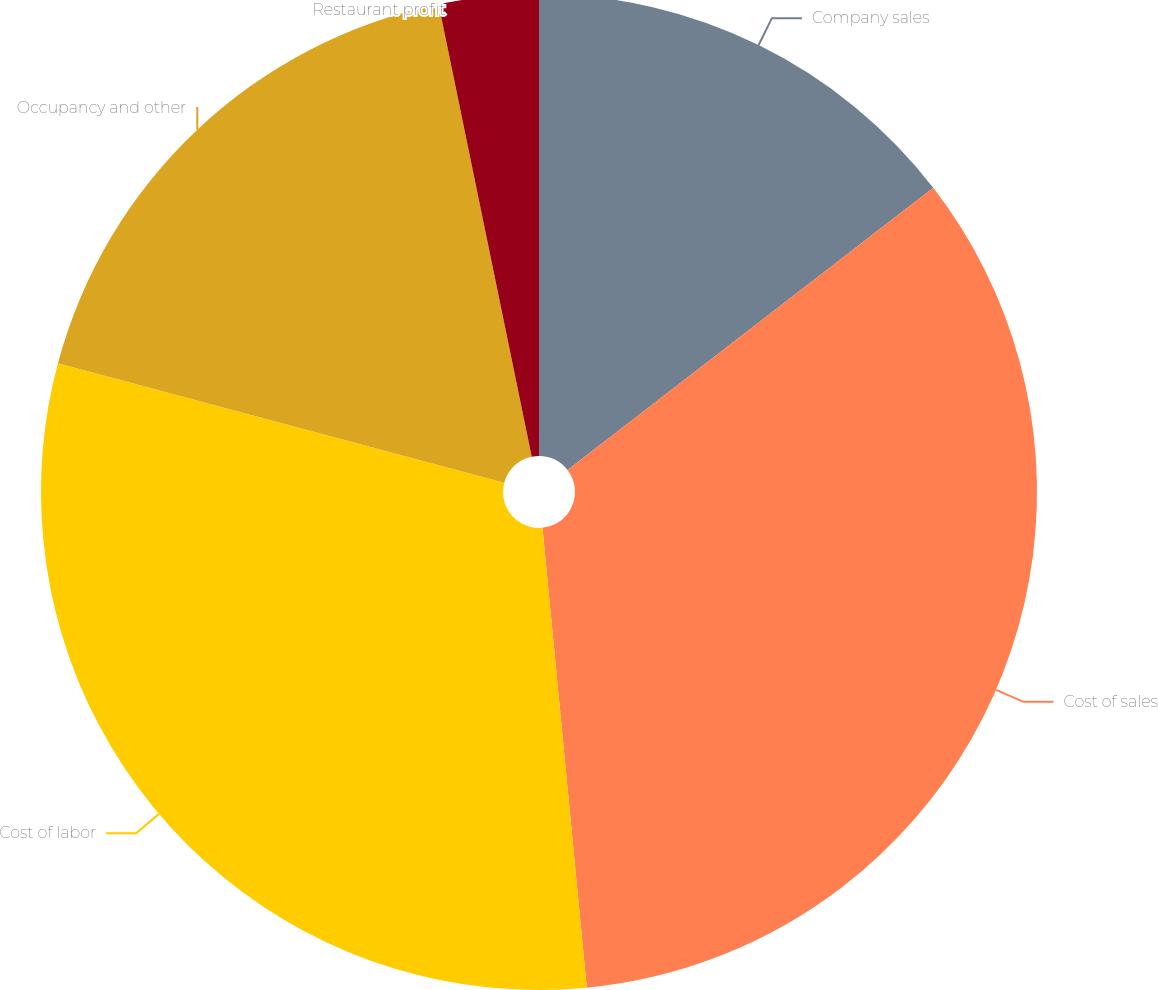Convert chart. <chart><loc_0><loc_0><loc_500><loc_500><pie_chart><fcel>Company sales<fcel>Cost of sales<fcel>Cost of labor<fcel>Occupancy and other<fcel>Restaurant profit<nl><fcel>14.54%<fcel>33.93%<fcel>30.69%<fcel>17.61%<fcel>3.23%<nl></chart> 